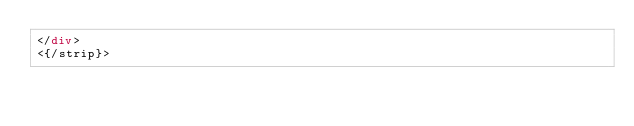Convert code to text. <code><loc_0><loc_0><loc_500><loc_500><_HTML_></div>
<{/strip}></code> 